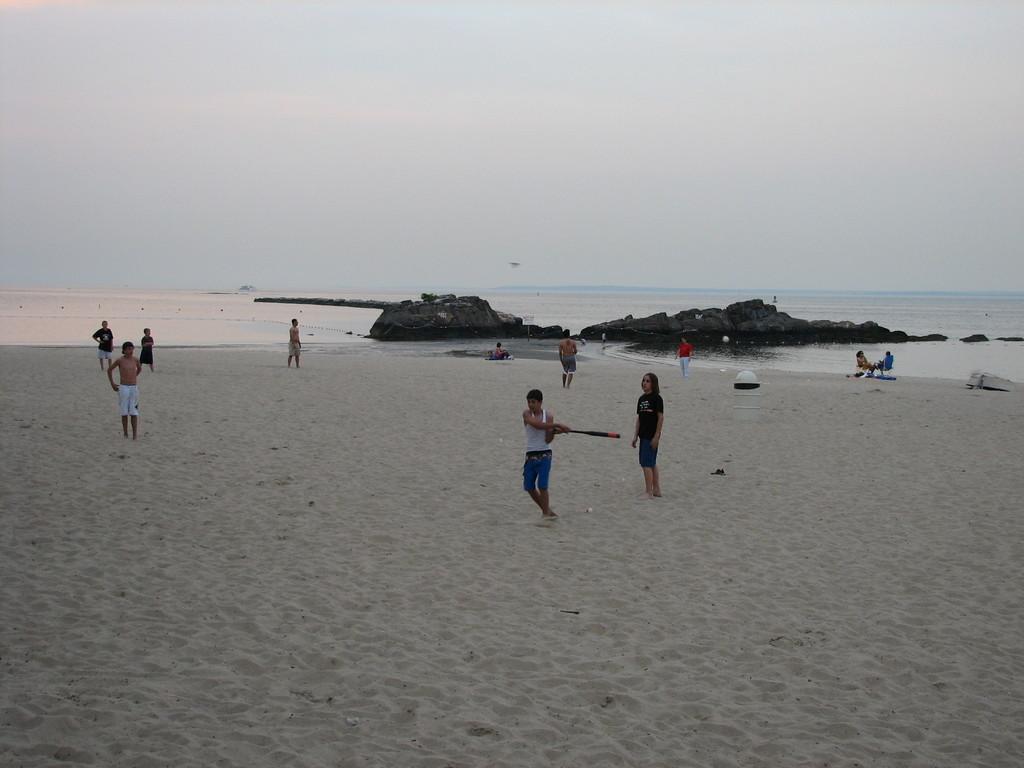In one or two sentences, can you explain what this image depicts? In this image I can see few people are standing on the sand. These people are wearing the different color dresses. I can see one person is holding the baseball bat. To the side of these people I can see the water and the rock. In the back I can see the white sky. 